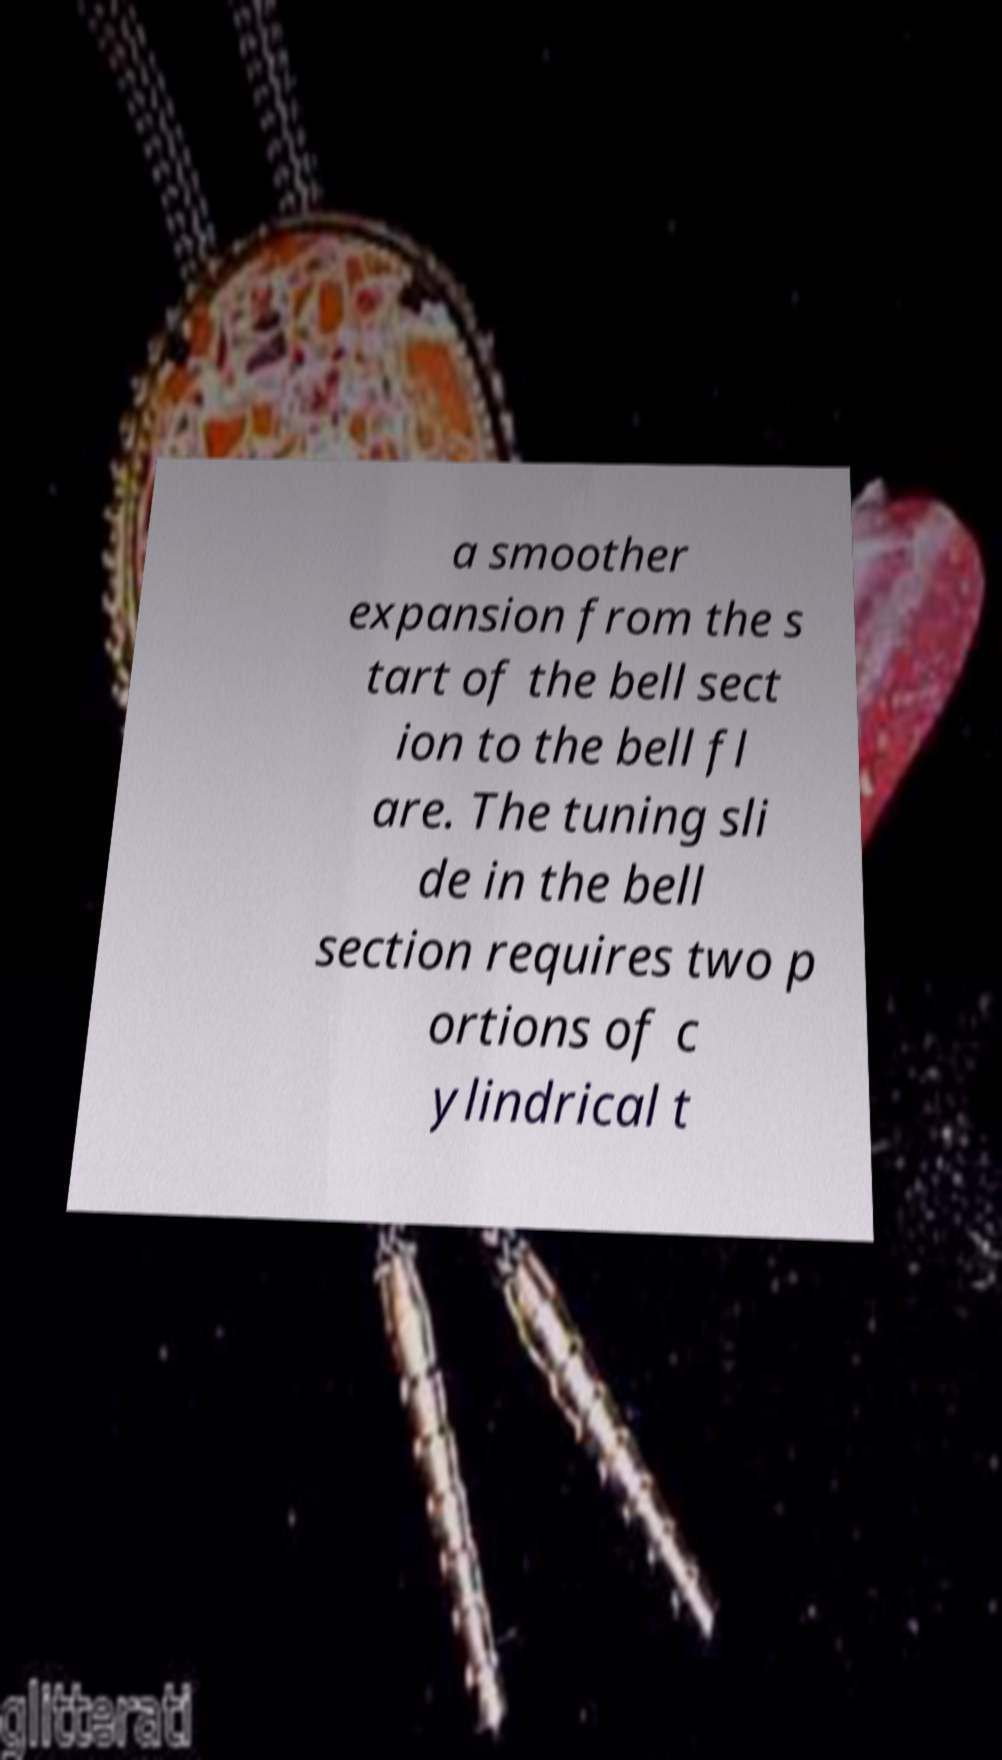There's text embedded in this image that I need extracted. Can you transcribe it verbatim? a smoother expansion from the s tart of the bell sect ion to the bell fl are. The tuning sli de in the bell section requires two p ortions of c ylindrical t 